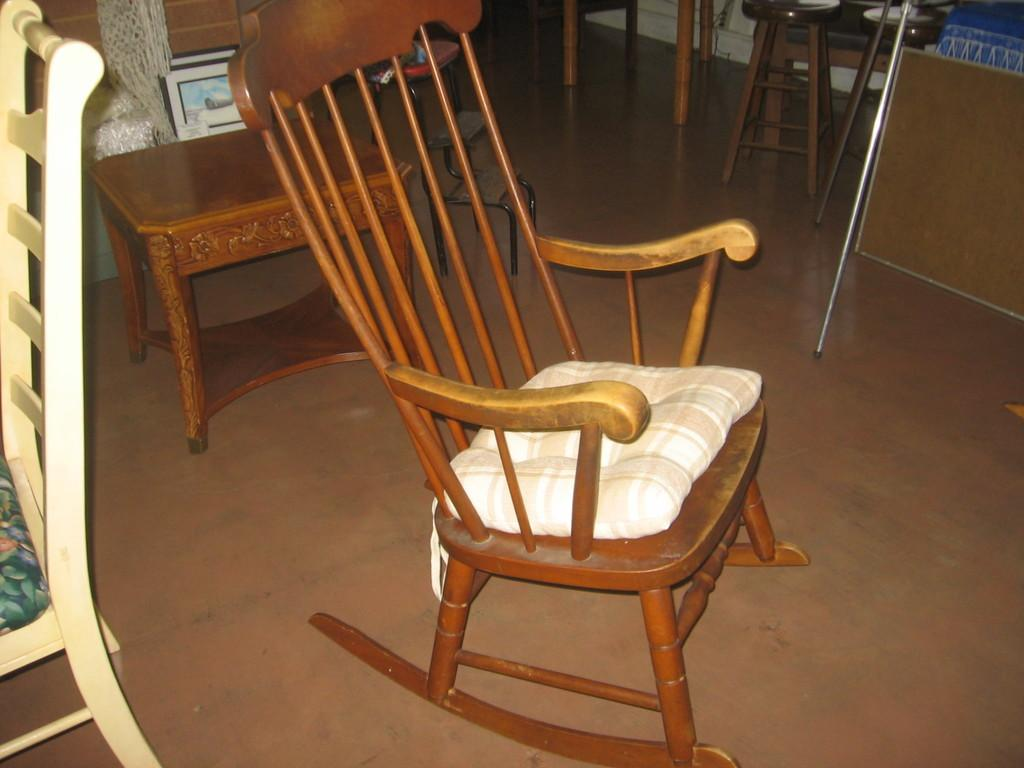What type of furniture is present in the image? There are chairs and stools in the image. What else can be seen in the image besides furniture? There is a photo frame and steel rods in the image. What color is the crayon being used to draw on the wing of the father in the image? There is no crayon, wing, or father present in the image. 